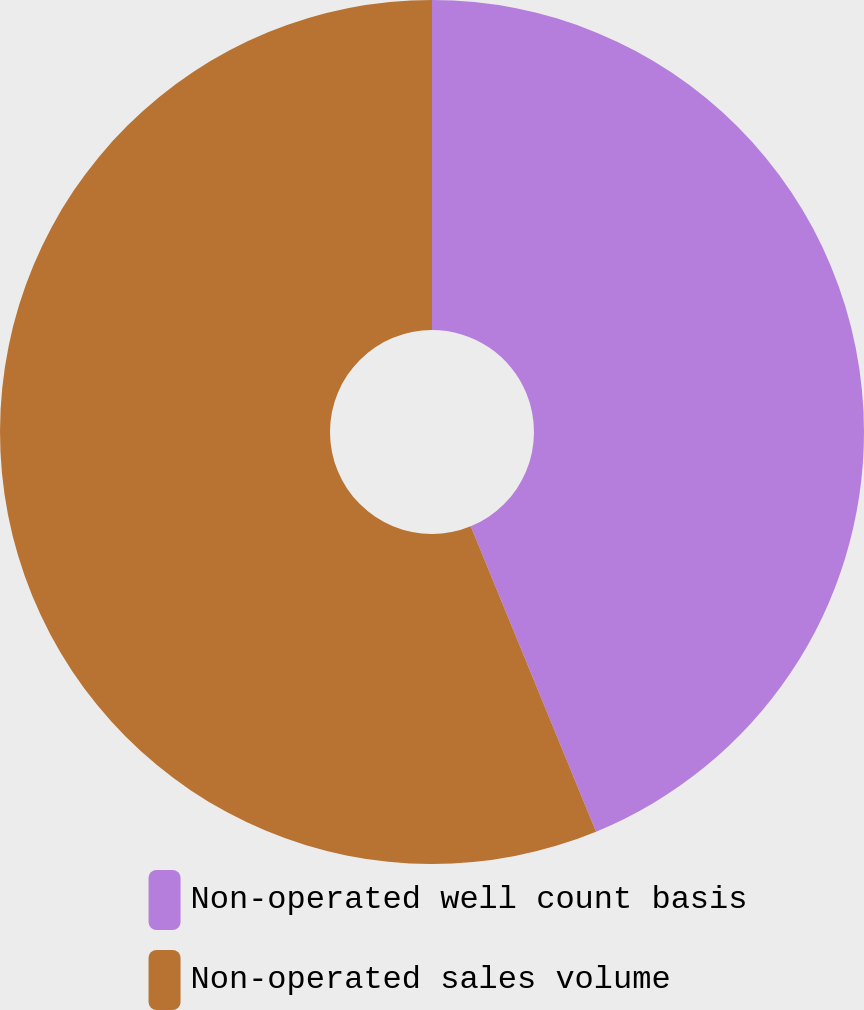Convert chart. <chart><loc_0><loc_0><loc_500><loc_500><pie_chart><fcel>Non-operated well count basis<fcel>Non-operated sales volume<nl><fcel>43.8%<fcel>56.2%<nl></chart> 